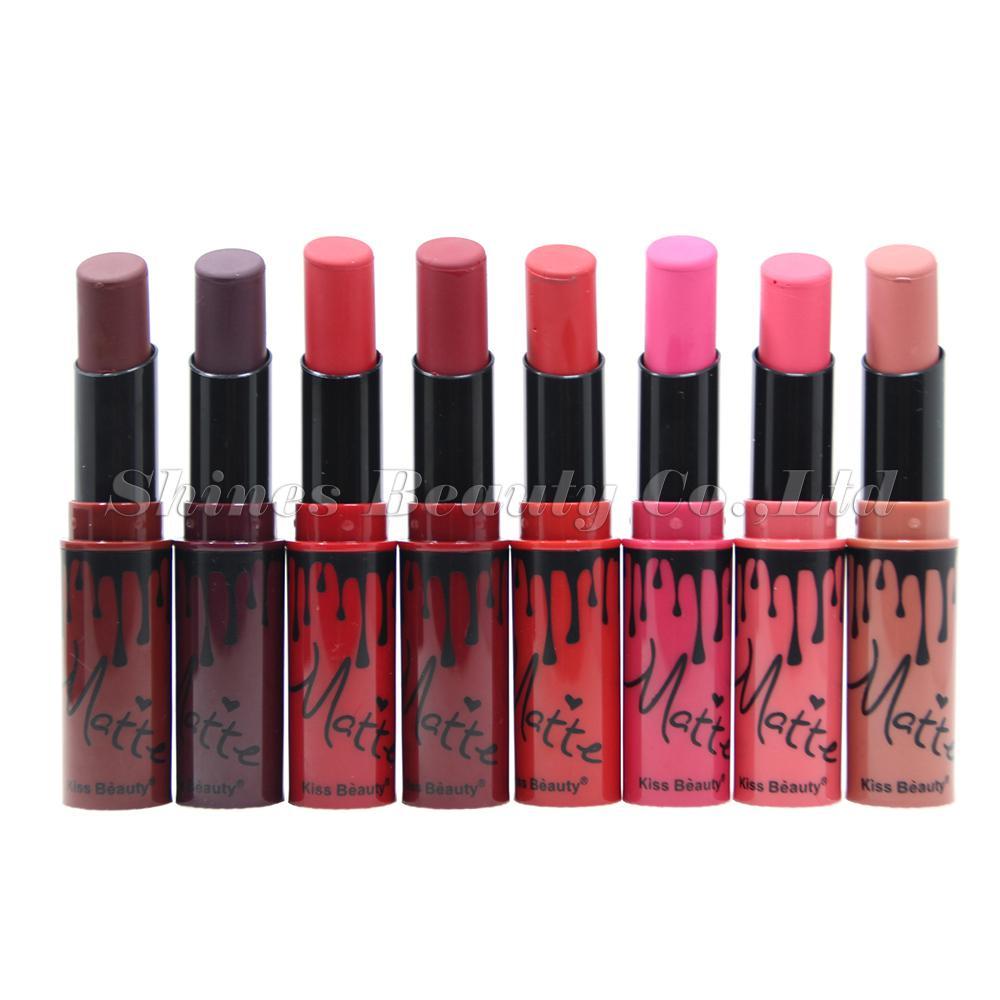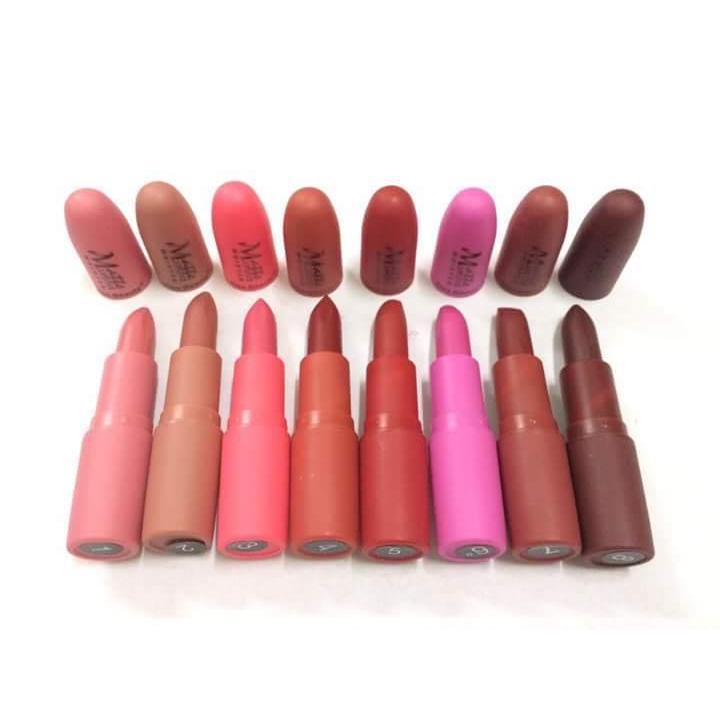The first image is the image on the left, the second image is the image on the right. For the images shown, is this caption "Each image in the pair shows the same number of uncapped lipsticks." true? Answer yes or no. Yes. 